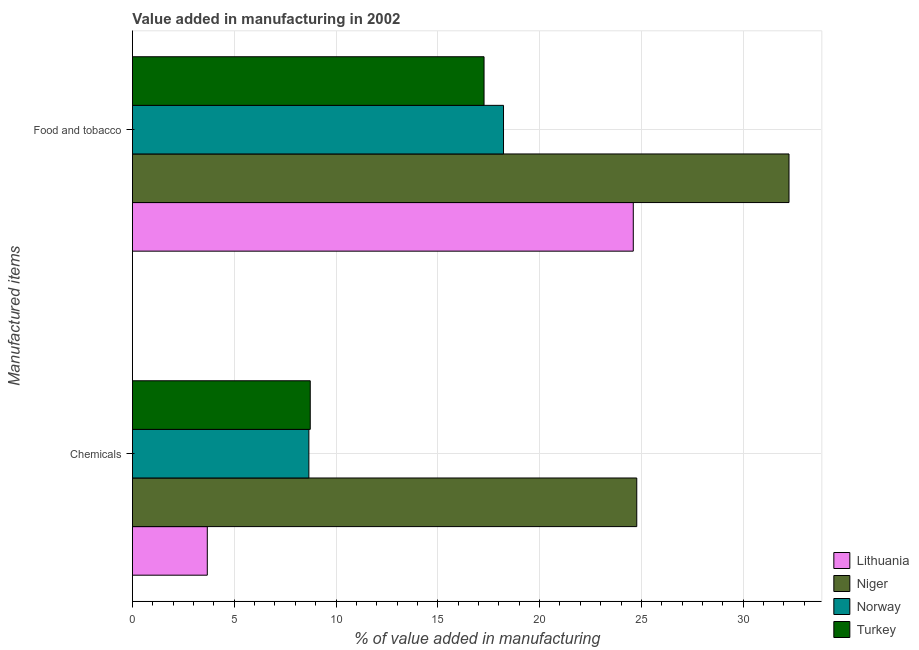How many groups of bars are there?
Offer a very short reply. 2. How many bars are there on the 2nd tick from the bottom?
Your answer should be compact. 4. What is the label of the 1st group of bars from the top?
Make the answer very short. Food and tobacco. What is the value added by manufacturing food and tobacco in Norway?
Give a very brief answer. 18.23. Across all countries, what is the maximum value added by  manufacturing chemicals?
Your answer should be very brief. 24.77. Across all countries, what is the minimum value added by manufacturing food and tobacco?
Keep it short and to the point. 17.27. In which country was the value added by manufacturing food and tobacco maximum?
Offer a very short reply. Niger. What is the total value added by  manufacturing chemicals in the graph?
Make the answer very short. 45.85. What is the difference between the value added by  manufacturing chemicals in Niger and that in Turkey?
Your answer should be very brief. 16.04. What is the difference between the value added by manufacturing food and tobacco in Niger and the value added by  manufacturing chemicals in Lithuania?
Make the answer very short. 28.57. What is the average value added by manufacturing food and tobacco per country?
Your answer should be compact. 23.09. What is the difference between the value added by manufacturing food and tobacco and value added by  manufacturing chemicals in Niger?
Keep it short and to the point. 7.48. In how many countries, is the value added by  manufacturing chemicals greater than 32 %?
Ensure brevity in your answer.  0. What is the ratio of the value added by  manufacturing chemicals in Lithuania to that in Niger?
Give a very brief answer. 0.15. In how many countries, is the value added by  manufacturing chemicals greater than the average value added by  manufacturing chemicals taken over all countries?
Keep it short and to the point. 1. What does the 2nd bar from the top in Food and tobacco represents?
Offer a very short reply. Norway. What does the 3rd bar from the bottom in Food and tobacco represents?
Ensure brevity in your answer.  Norway. How many bars are there?
Provide a short and direct response. 8. Are all the bars in the graph horizontal?
Your answer should be compact. Yes. What is the difference between two consecutive major ticks on the X-axis?
Keep it short and to the point. 5. Are the values on the major ticks of X-axis written in scientific E-notation?
Keep it short and to the point. No. Does the graph contain any zero values?
Keep it short and to the point. No. Where does the legend appear in the graph?
Ensure brevity in your answer.  Bottom right. What is the title of the graph?
Make the answer very short. Value added in manufacturing in 2002. Does "Angola" appear as one of the legend labels in the graph?
Make the answer very short. No. What is the label or title of the X-axis?
Your response must be concise. % of value added in manufacturing. What is the label or title of the Y-axis?
Offer a terse response. Manufactured items. What is the % of value added in manufacturing in Lithuania in Chemicals?
Provide a short and direct response. 3.68. What is the % of value added in manufacturing of Niger in Chemicals?
Your answer should be very brief. 24.77. What is the % of value added in manufacturing of Norway in Chemicals?
Give a very brief answer. 8.67. What is the % of value added in manufacturing in Turkey in Chemicals?
Offer a very short reply. 8.73. What is the % of value added in manufacturing in Lithuania in Food and tobacco?
Make the answer very short. 24.6. What is the % of value added in manufacturing in Niger in Food and tobacco?
Offer a terse response. 32.25. What is the % of value added in manufacturing in Norway in Food and tobacco?
Your response must be concise. 18.23. What is the % of value added in manufacturing in Turkey in Food and tobacco?
Offer a very short reply. 17.27. Across all Manufactured items, what is the maximum % of value added in manufacturing of Lithuania?
Keep it short and to the point. 24.6. Across all Manufactured items, what is the maximum % of value added in manufacturing of Niger?
Ensure brevity in your answer.  32.25. Across all Manufactured items, what is the maximum % of value added in manufacturing in Norway?
Give a very brief answer. 18.23. Across all Manufactured items, what is the maximum % of value added in manufacturing in Turkey?
Ensure brevity in your answer.  17.27. Across all Manufactured items, what is the minimum % of value added in manufacturing in Lithuania?
Your answer should be very brief. 3.68. Across all Manufactured items, what is the minimum % of value added in manufacturing in Niger?
Give a very brief answer. 24.77. Across all Manufactured items, what is the minimum % of value added in manufacturing of Norway?
Your answer should be compact. 8.67. Across all Manufactured items, what is the minimum % of value added in manufacturing of Turkey?
Your response must be concise. 8.73. What is the total % of value added in manufacturing in Lithuania in the graph?
Your answer should be very brief. 28.28. What is the total % of value added in manufacturing of Niger in the graph?
Provide a succinct answer. 57.02. What is the total % of value added in manufacturing of Norway in the graph?
Your answer should be compact. 26.89. What is the total % of value added in manufacturing of Turkey in the graph?
Provide a succinct answer. 26. What is the difference between the % of value added in manufacturing of Lithuania in Chemicals and that in Food and tobacco?
Your answer should be compact. -20.92. What is the difference between the % of value added in manufacturing in Niger in Chemicals and that in Food and tobacco?
Offer a very short reply. -7.48. What is the difference between the % of value added in manufacturing in Norway in Chemicals and that in Food and tobacco?
Your answer should be very brief. -9.56. What is the difference between the % of value added in manufacturing in Turkey in Chemicals and that in Food and tobacco?
Your answer should be compact. -8.54. What is the difference between the % of value added in manufacturing of Lithuania in Chemicals and the % of value added in manufacturing of Niger in Food and tobacco?
Give a very brief answer. -28.57. What is the difference between the % of value added in manufacturing of Lithuania in Chemicals and the % of value added in manufacturing of Norway in Food and tobacco?
Your answer should be very brief. -14.55. What is the difference between the % of value added in manufacturing of Lithuania in Chemicals and the % of value added in manufacturing of Turkey in Food and tobacco?
Keep it short and to the point. -13.59. What is the difference between the % of value added in manufacturing of Niger in Chemicals and the % of value added in manufacturing of Norway in Food and tobacco?
Your answer should be compact. 6.54. What is the difference between the % of value added in manufacturing of Niger in Chemicals and the % of value added in manufacturing of Turkey in Food and tobacco?
Offer a very short reply. 7.5. What is the difference between the % of value added in manufacturing of Norway in Chemicals and the % of value added in manufacturing of Turkey in Food and tobacco?
Provide a succinct answer. -8.6. What is the average % of value added in manufacturing in Lithuania per Manufactured items?
Give a very brief answer. 14.14. What is the average % of value added in manufacturing in Niger per Manufactured items?
Your response must be concise. 28.51. What is the average % of value added in manufacturing in Norway per Manufactured items?
Offer a terse response. 13.45. What is the average % of value added in manufacturing in Turkey per Manufactured items?
Your answer should be compact. 13. What is the difference between the % of value added in manufacturing of Lithuania and % of value added in manufacturing of Niger in Chemicals?
Your answer should be very brief. -21.09. What is the difference between the % of value added in manufacturing in Lithuania and % of value added in manufacturing in Norway in Chemicals?
Make the answer very short. -4.99. What is the difference between the % of value added in manufacturing of Lithuania and % of value added in manufacturing of Turkey in Chemicals?
Provide a short and direct response. -5.06. What is the difference between the % of value added in manufacturing in Niger and % of value added in manufacturing in Norway in Chemicals?
Your answer should be very brief. 16.11. What is the difference between the % of value added in manufacturing in Niger and % of value added in manufacturing in Turkey in Chemicals?
Offer a terse response. 16.04. What is the difference between the % of value added in manufacturing of Norway and % of value added in manufacturing of Turkey in Chemicals?
Ensure brevity in your answer.  -0.07. What is the difference between the % of value added in manufacturing in Lithuania and % of value added in manufacturing in Niger in Food and tobacco?
Offer a terse response. -7.65. What is the difference between the % of value added in manufacturing in Lithuania and % of value added in manufacturing in Norway in Food and tobacco?
Keep it short and to the point. 6.37. What is the difference between the % of value added in manufacturing of Lithuania and % of value added in manufacturing of Turkey in Food and tobacco?
Your answer should be compact. 7.33. What is the difference between the % of value added in manufacturing of Niger and % of value added in manufacturing of Norway in Food and tobacco?
Your response must be concise. 14.02. What is the difference between the % of value added in manufacturing in Niger and % of value added in manufacturing in Turkey in Food and tobacco?
Offer a very short reply. 14.98. What is the difference between the % of value added in manufacturing in Norway and % of value added in manufacturing in Turkey in Food and tobacco?
Offer a very short reply. 0.96. What is the ratio of the % of value added in manufacturing of Lithuania in Chemicals to that in Food and tobacco?
Offer a terse response. 0.15. What is the ratio of the % of value added in manufacturing of Niger in Chemicals to that in Food and tobacco?
Provide a short and direct response. 0.77. What is the ratio of the % of value added in manufacturing of Norway in Chemicals to that in Food and tobacco?
Your response must be concise. 0.48. What is the ratio of the % of value added in manufacturing in Turkey in Chemicals to that in Food and tobacco?
Keep it short and to the point. 0.51. What is the difference between the highest and the second highest % of value added in manufacturing of Lithuania?
Provide a short and direct response. 20.92. What is the difference between the highest and the second highest % of value added in manufacturing in Niger?
Offer a terse response. 7.48. What is the difference between the highest and the second highest % of value added in manufacturing in Norway?
Ensure brevity in your answer.  9.56. What is the difference between the highest and the second highest % of value added in manufacturing in Turkey?
Provide a short and direct response. 8.54. What is the difference between the highest and the lowest % of value added in manufacturing in Lithuania?
Your response must be concise. 20.92. What is the difference between the highest and the lowest % of value added in manufacturing in Niger?
Offer a terse response. 7.48. What is the difference between the highest and the lowest % of value added in manufacturing in Norway?
Provide a short and direct response. 9.56. What is the difference between the highest and the lowest % of value added in manufacturing of Turkey?
Your answer should be very brief. 8.54. 